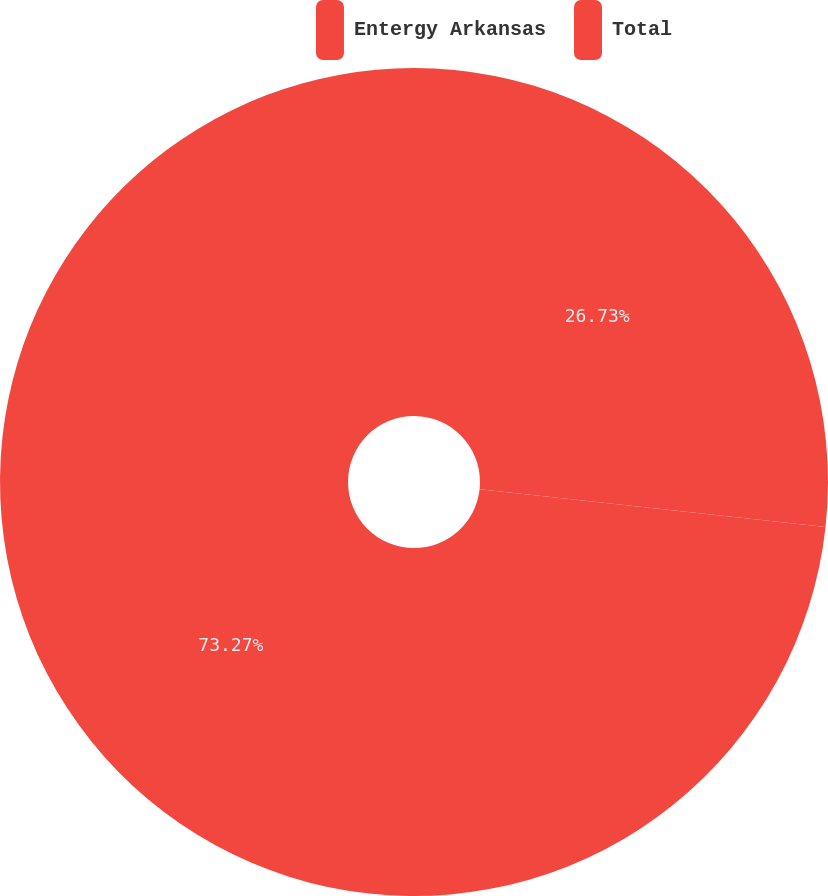Convert chart to OTSL. <chart><loc_0><loc_0><loc_500><loc_500><pie_chart><fcel>Entergy Arkansas<fcel>Total<nl><fcel>26.73%<fcel>73.27%<nl></chart> 